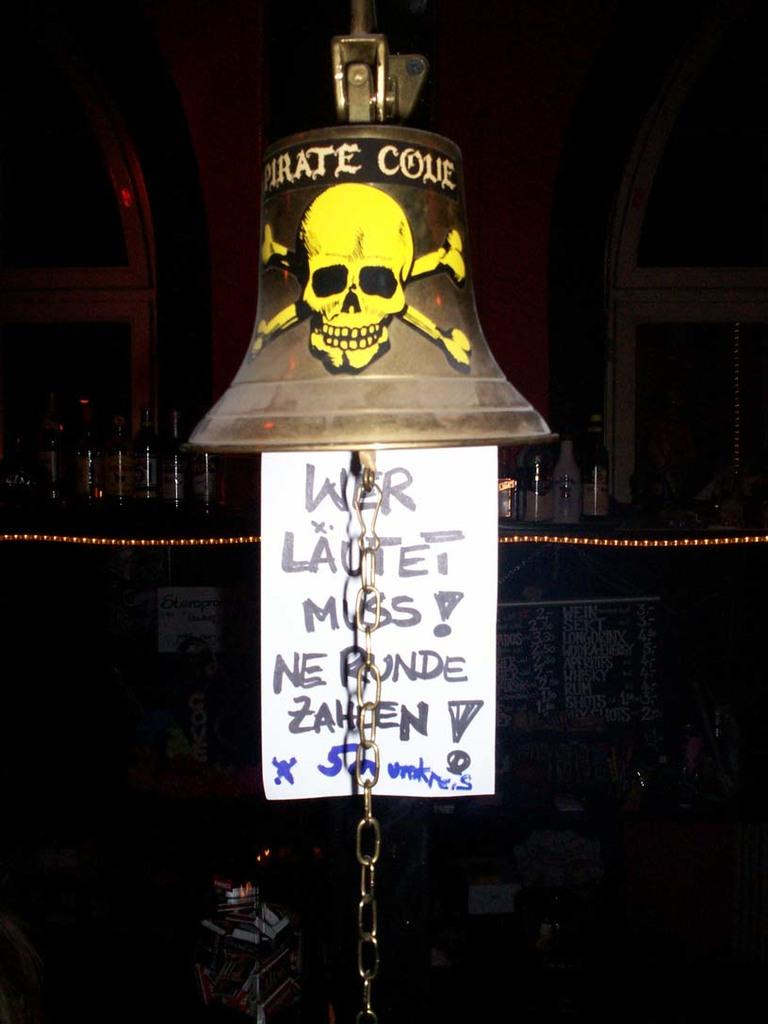What object is the main focus of the image? There is a bell in the image. What is depicted on the bell? There is a skull picture on the bell. What else can be seen in the image besides the bell? There is a poster hanging in the image. How would you describe the overall appearance of the image? The background of the image is dark. What type of paint is being used to create the library in the image? There is no library present in the image, so it is not possible to determine what type of paint might be used. 